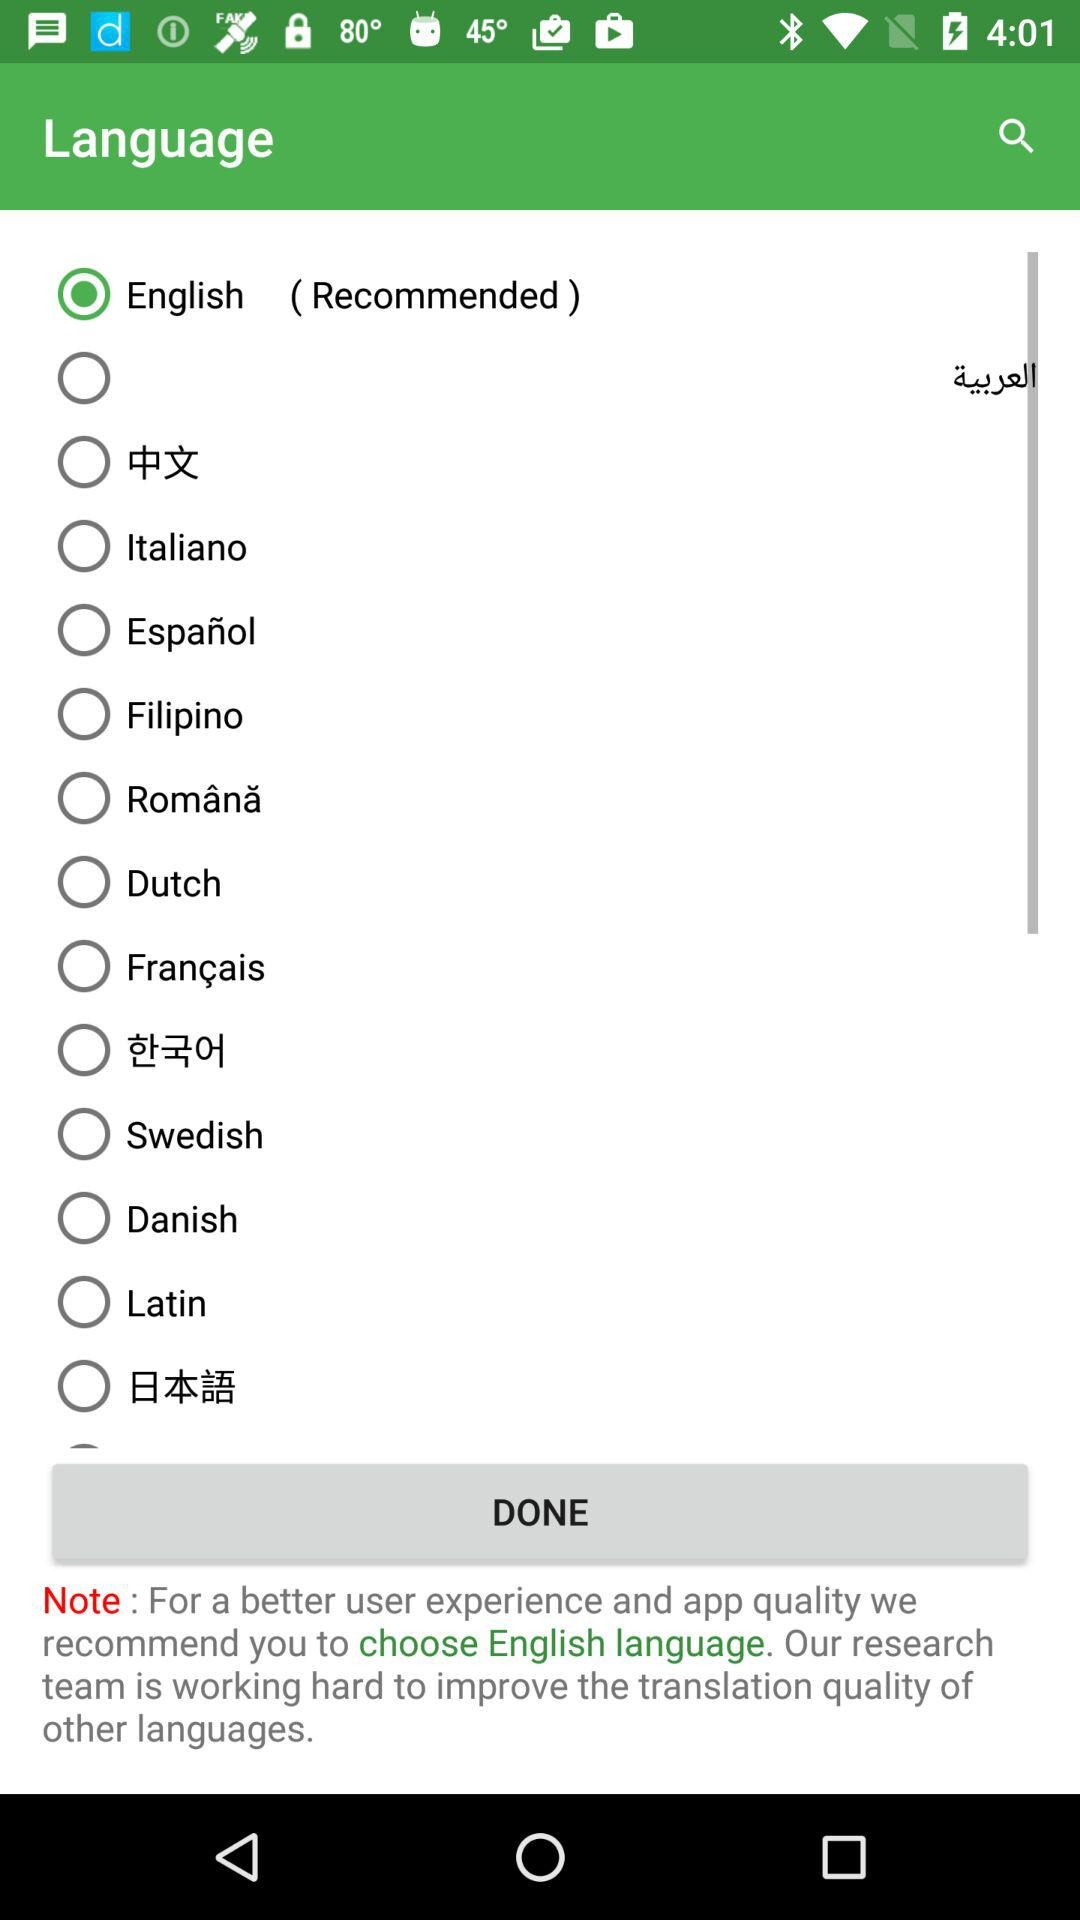Which language is selected? The selected language is "English". 